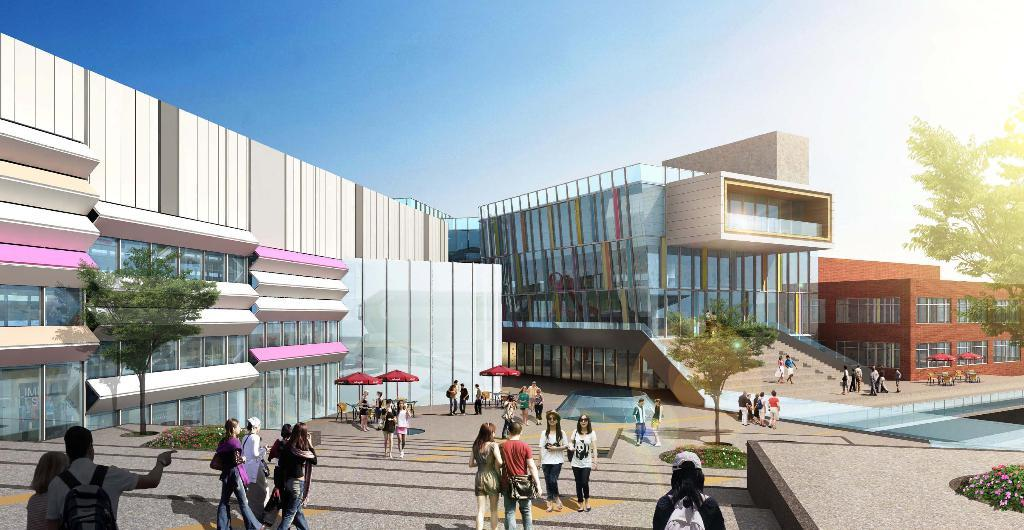What is the main subject in the center of the image? There are buildings in the center of the image. Where are the people located in the image? The people are at the bottom side of the image. What type of vegetation is on the right side of the image? There is a tree on the right side of the image. What color is the silver friend in the image? There is no silver friend present in the image. How does the earth interact with the buildings in the image? The image does not depict the earth interacting with the buildings; it only shows the buildings themselves. 